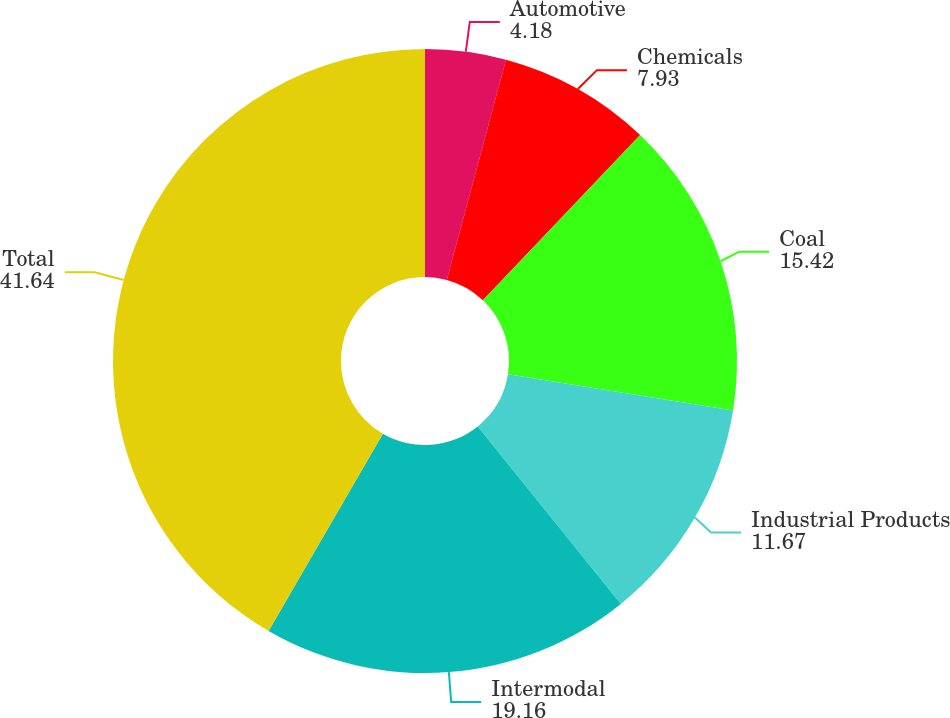Convert chart to OTSL. <chart><loc_0><loc_0><loc_500><loc_500><pie_chart><fcel>Automotive<fcel>Chemicals<fcel>Coal<fcel>Industrial Products<fcel>Intermodal<fcel>Total<nl><fcel>4.18%<fcel>7.93%<fcel>15.42%<fcel>11.67%<fcel>19.16%<fcel>41.64%<nl></chart> 